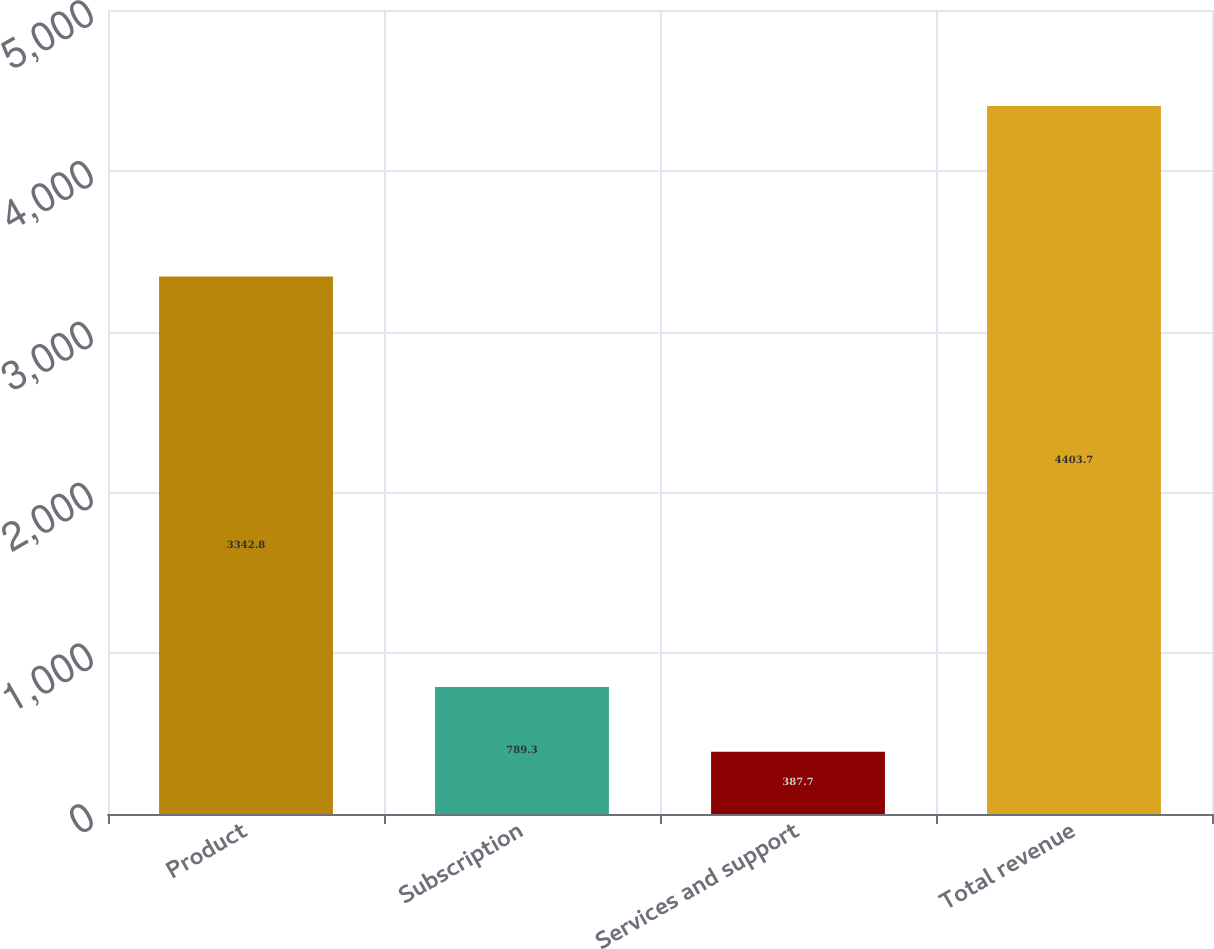<chart> <loc_0><loc_0><loc_500><loc_500><bar_chart><fcel>Product<fcel>Subscription<fcel>Services and support<fcel>Total revenue<nl><fcel>3342.8<fcel>789.3<fcel>387.7<fcel>4403.7<nl></chart> 